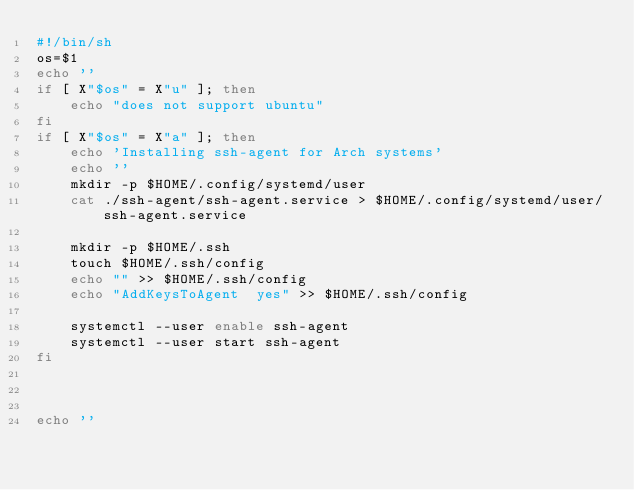<code> <loc_0><loc_0><loc_500><loc_500><_Bash_>#!/bin/sh
os=$1
echo ''
if [ X"$os" = X"u" ]; then
    echo "does not support ubuntu"
fi
if [ X"$os" = X"a" ]; then
    echo 'Installing ssh-agent for Arch systems'
    echo ''
    mkdir -p $HOME/.config/systemd/user
    cat ./ssh-agent/ssh-agent.service > $HOME/.config/systemd/user/ssh-agent.service

    mkdir -p $HOME/.ssh
    touch $HOME/.ssh/config
    echo "" >> $HOME/.ssh/config
    echo "AddKeysToAgent  yes" >> $HOME/.ssh/config

    systemctl --user enable ssh-agent
    systemctl --user start ssh-agent
fi



echo ''
</code> 